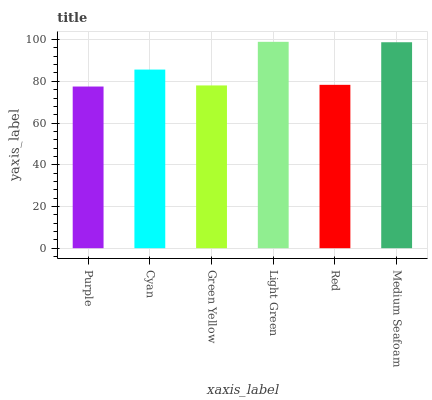Is Purple the minimum?
Answer yes or no. Yes. Is Light Green the maximum?
Answer yes or no. Yes. Is Cyan the minimum?
Answer yes or no. No. Is Cyan the maximum?
Answer yes or no. No. Is Cyan greater than Purple?
Answer yes or no. Yes. Is Purple less than Cyan?
Answer yes or no. Yes. Is Purple greater than Cyan?
Answer yes or no. No. Is Cyan less than Purple?
Answer yes or no. No. Is Cyan the high median?
Answer yes or no. Yes. Is Red the low median?
Answer yes or no. Yes. Is Green Yellow the high median?
Answer yes or no. No. Is Purple the low median?
Answer yes or no. No. 